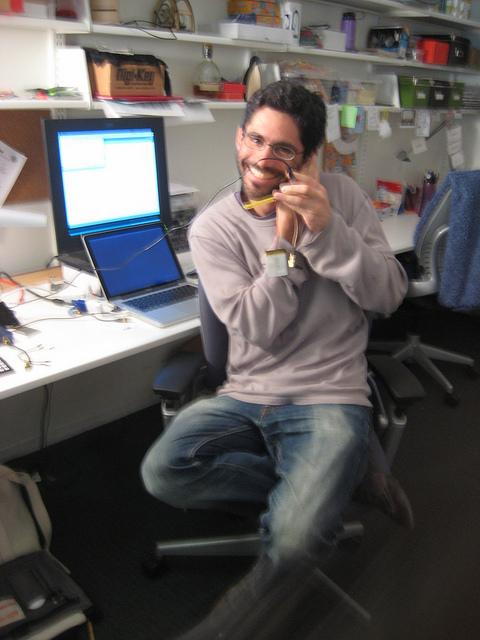How many computers can you see?
Write a very short answer. 2. Is this man working?
Answer briefly. Yes. Why is the guy smiling?
Answer briefly. Happy. 